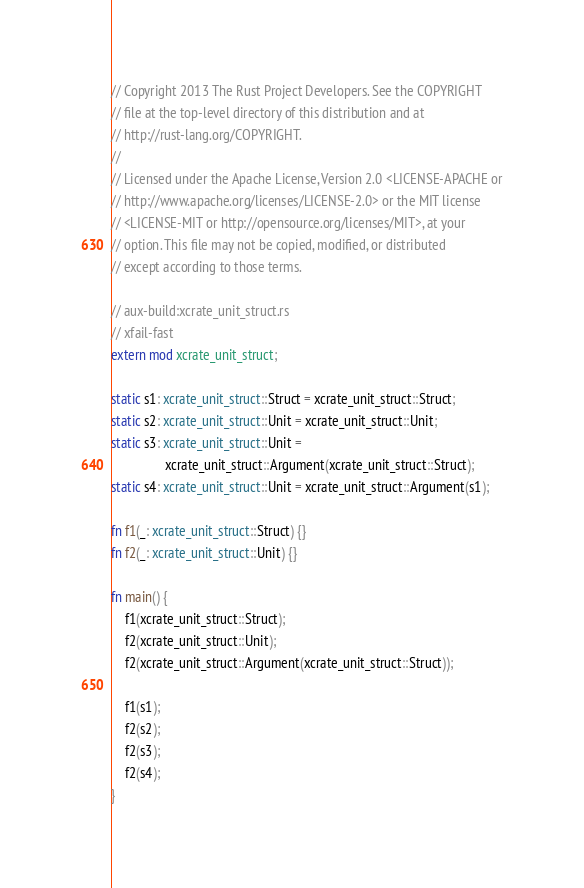Convert code to text. <code><loc_0><loc_0><loc_500><loc_500><_Rust_>// Copyright 2013 The Rust Project Developers. See the COPYRIGHT
// file at the top-level directory of this distribution and at
// http://rust-lang.org/COPYRIGHT.
//
// Licensed under the Apache License, Version 2.0 <LICENSE-APACHE or
// http://www.apache.org/licenses/LICENSE-2.0> or the MIT license
// <LICENSE-MIT or http://opensource.org/licenses/MIT>, at your
// option. This file may not be copied, modified, or distributed
// except according to those terms.

// aux-build:xcrate_unit_struct.rs
// xfail-fast
extern mod xcrate_unit_struct;

static s1: xcrate_unit_struct::Struct = xcrate_unit_struct::Struct;
static s2: xcrate_unit_struct::Unit = xcrate_unit_struct::Unit;
static s3: xcrate_unit_struct::Unit =
                xcrate_unit_struct::Argument(xcrate_unit_struct::Struct);
static s4: xcrate_unit_struct::Unit = xcrate_unit_struct::Argument(s1);

fn f1(_: xcrate_unit_struct::Struct) {}
fn f2(_: xcrate_unit_struct::Unit) {}

fn main() {
    f1(xcrate_unit_struct::Struct);
    f2(xcrate_unit_struct::Unit);
    f2(xcrate_unit_struct::Argument(xcrate_unit_struct::Struct));

    f1(s1);
    f2(s2);
    f2(s3);
    f2(s4);
}
</code> 